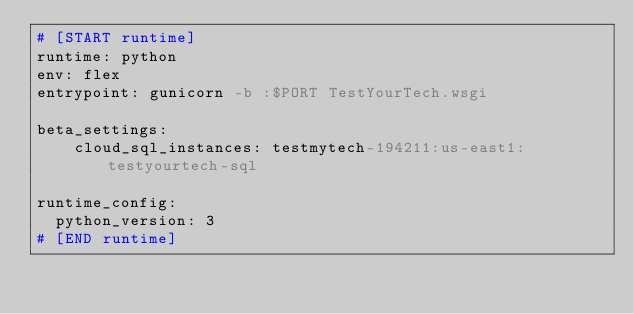Convert code to text. <code><loc_0><loc_0><loc_500><loc_500><_YAML_># [START runtime]
runtime: python
env: flex
entrypoint: gunicorn -b :$PORT TestYourTech.wsgi

beta_settings:
    cloud_sql_instances: testmytech-194211:us-east1:testyourtech-sql

runtime_config:
  python_version: 3
# [END runtime]
</code> 